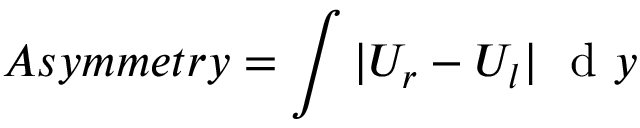Convert formula to latex. <formula><loc_0><loc_0><loc_500><loc_500>A s y m m e t r y = \int | U _ { r } - U _ { l } | d y</formula> 